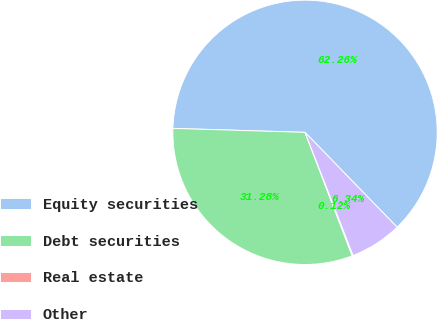Convert chart to OTSL. <chart><loc_0><loc_0><loc_500><loc_500><pie_chart><fcel>Equity securities<fcel>Debt securities<fcel>Real estate<fcel>Other<nl><fcel>62.26%<fcel>31.28%<fcel>0.12%<fcel>6.34%<nl></chart> 